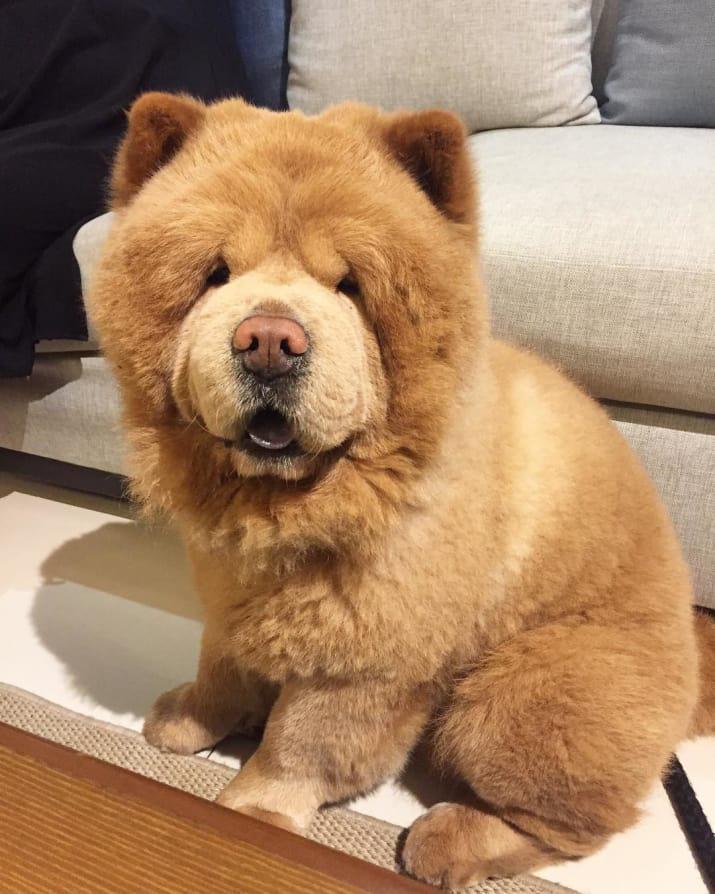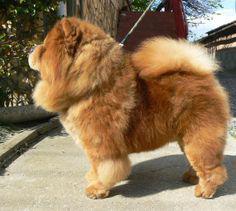The first image is the image on the left, the second image is the image on the right. Examine the images to the left and right. Is the description "The right image contains one chow dog attached to a leash." accurate? Answer yes or no. Yes. The first image is the image on the left, the second image is the image on the right. For the images shown, is this caption "One dog is sitting and one is standing." true? Answer yes or no. Yes. 